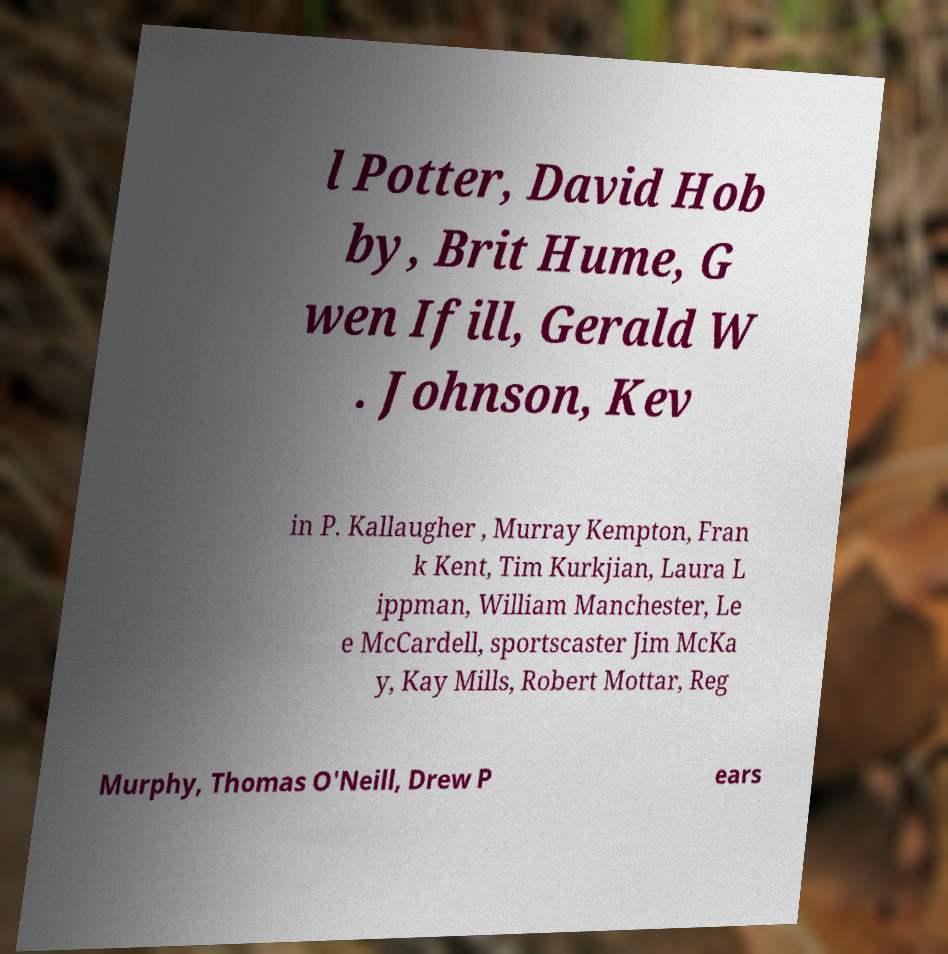Could you extract and type out the text from this image? l Potter, David Hob by, Brit Hume, G wen Ifill, Gerald W . Johnson, Kev in P. Kallaugher , Murray Kempton, Fran k Kent, Tim Kurkjian, Laura L ippman, William Manchester, Le e McCardell, sportscaster Jim McKa y, Kay Mills, Robert Mottar, Reg Murphy, Thomas O'Neill, Drew P ears 